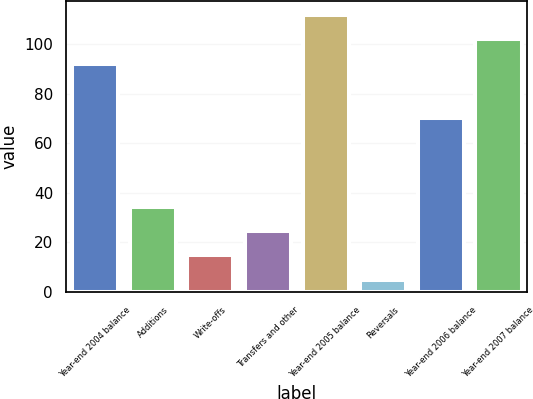<chart> <loc_0><loc_0><loc_500><loc_500><bar_chart><fcel>Year-end 2004 balance<fcel>Additions<fcel>Write-offs<fcel>Transfers and other<fcel>Year-end 2005 balance<fcel>Reversals<fcel>Year-end 2006 balance<fcel>Year-end 2007 balance<nl><fcel>92<fcel>34.4<fcel>14.8<fcel>24.6<fcel>111.6<fcel>5<fcel>70<fcel>101.8<nl></chart> 